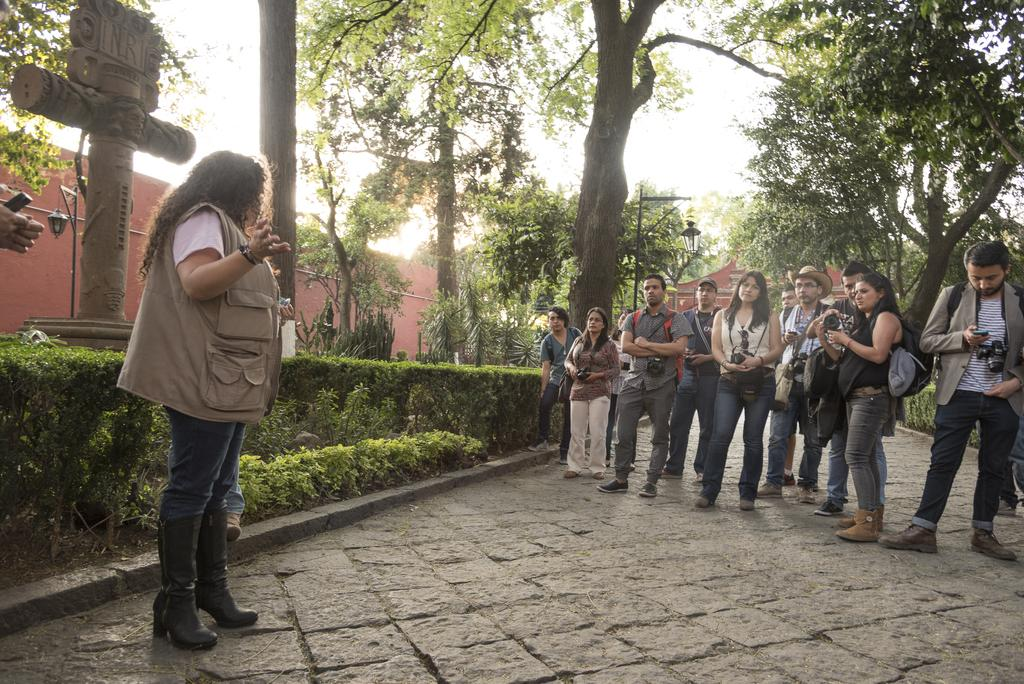Who or what can be seen in the image? There are people in the image. What else is present in the image besides people? There are plants, trees, a street lamp, buildings, and some people holding cameras in their hands. Can you describe the environment in the image? The image features a combination of natural elements, such as plants and trees, as well as man-made structures like buildings and a street lamp. What might the people holding cameras be doing? They might be taking photographs or capturing the scene in the image. What type of list can be seen on the ground in the image? There is no list present on the ground in the image. 